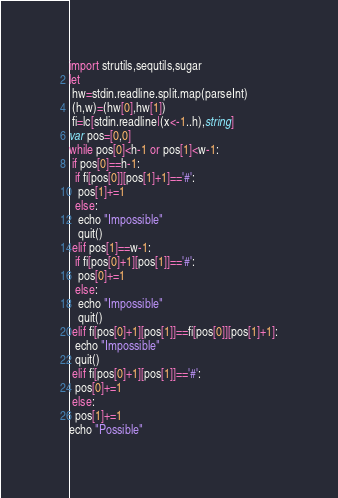<code> <loc_0><loc_0><loc_500><loc_500><_Nim_>import strutils,sequtils,sugar
let
 hw=stdin.readline.split.map(parseInt)
 (h,w)=(hw[0],hw[1])
 fi=lc[stdin.readline|(x<-1..h),string]
var pos=[0,0]
while pos[0]<h-1 or pos[1]<w-1:
 if pos[0]==h-1:
  if fi[pos[0]][pos[1]+1]=='#':
   pos[1]+=1
  else:
   echo "Impossible"
   quit()
 elif pos[1]==w-1:
  if fi[pos[0]+1][pos[1]]=='#':
   pos[0]+=1
  else:
   echo "Impossible"
   quit()
 elif fi[pos[0]+1][pos[1]]==fi[pos[0]][pos[1]+1]:
  echo "Impossible"
  quit()
 elif fi[pos[0]+1][pos[1]]=='#':
  pos[0]+=1
 else:
  pos[1]+=1
echo "Possible"</code> 